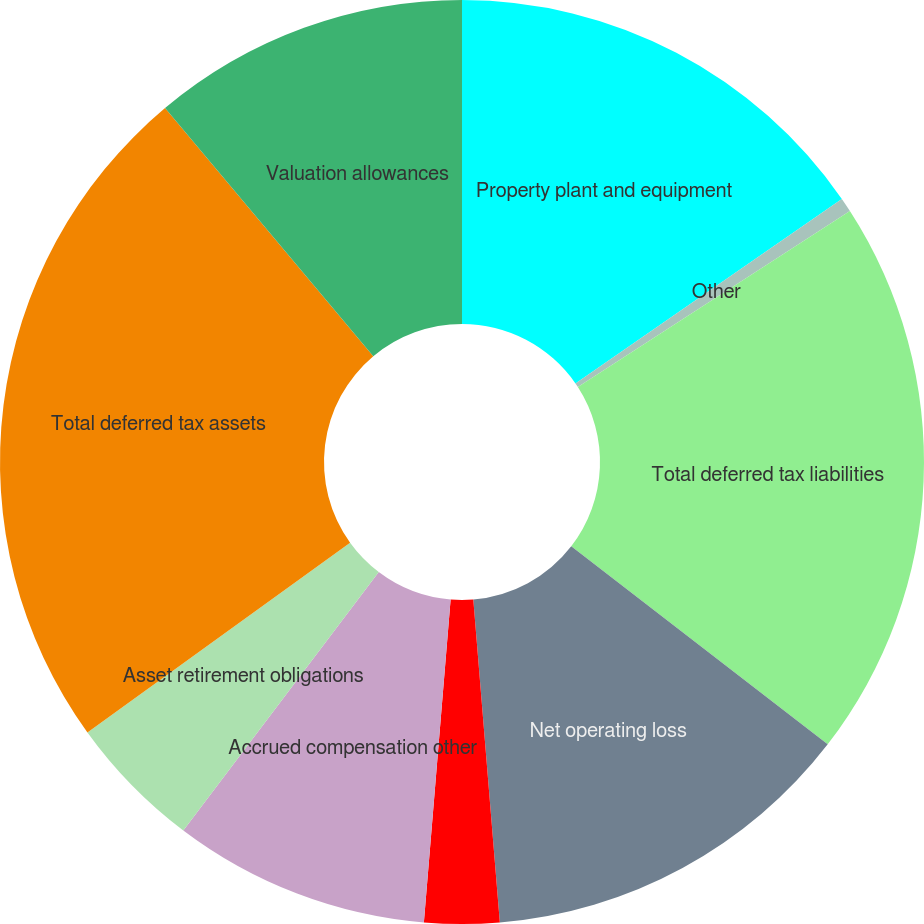Convert chart to OTSL. <chart><loc_0><loc_0><loc_500><loc_500><pie_chart><fcel>Property plant and equipment<fcel>Other<fcel>Total deferred tax liabilities<fcel>Net operating loss<fcel>Tax credit carryforwards<fcel>Accrued compensation other<fcel>Asset retirement obligations<fcel>Total deferred tax assets<fcel>Valuation allowances<nl><fcel>15.36%<fcel>0.5%<fcel>19.6%<fcel>13.23%<fcel>2.62%<fcel>8.99%<fcel>4.74%<fcel>23.84%<fcel>11.11%<nl></chart> 